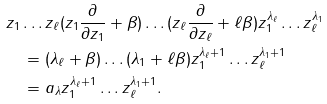<formula> <loc_0><loc_0><loc_500><loc_500>& z _ { 1 } \dots z _ { \ell } ( z _ { 1 } \frac { \partial } { \partial z _ { 1 } } + \beta ) \dots ( z _ { \ell } \frac { \partial } { \partial z _ { \ell } } + \ell \beta ) z _ { 1 } ^ { \lambda _ { \ell } } \dots z _ { \ell } ^ { \lambda _ { 1 } } \\ & \quad = ( \lambda _ { \ell } + \beta ) \dots ( \lambda _ { 1 } + \ell \beta ) z _ { 1 } ^ { \lambda _ { \ell } + 1 } \dots z _ { \ell } ^ { \lambda _ { 1 } + 1 } \\ & \quad = a _ { \lambda } z _ { 1 } ^ { \lambda _ { \ell } + 1 } \dots z _ { \ell } ^ { \lambda _ { 1 } + 1 } .</formula> 